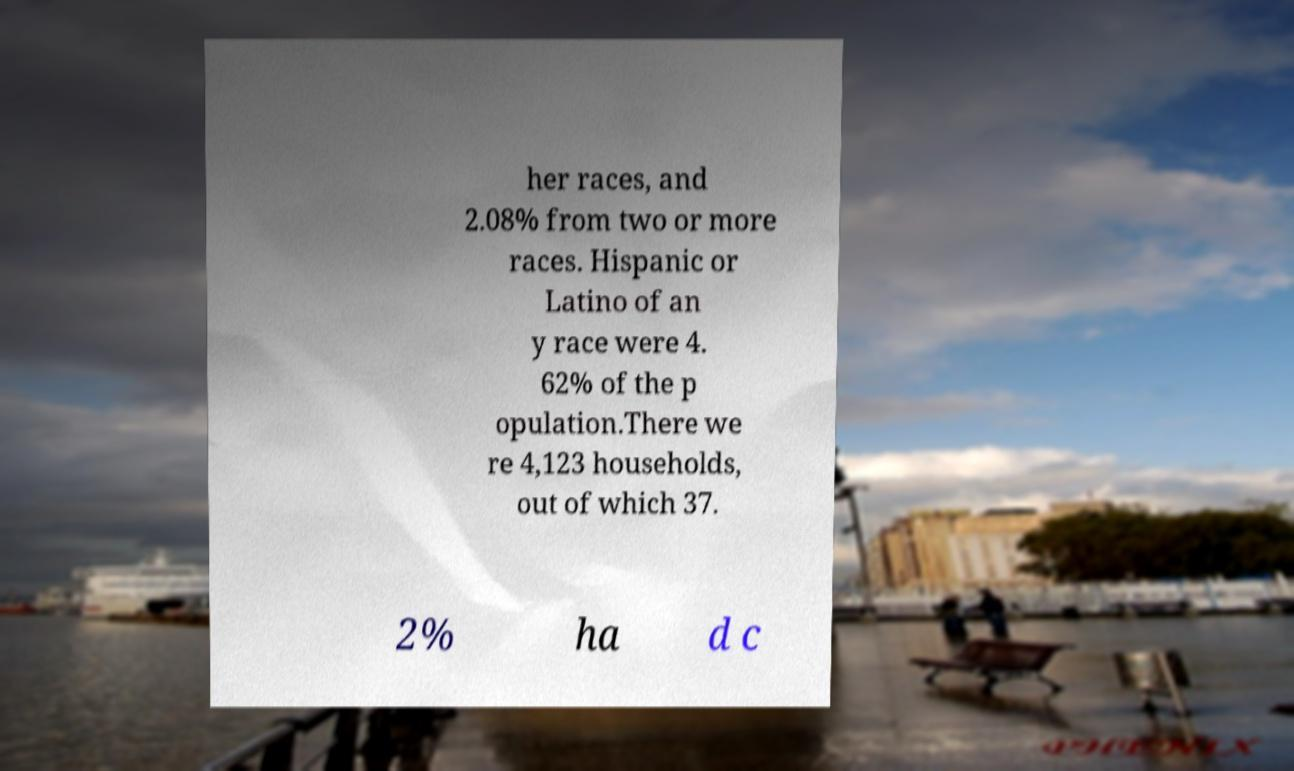Can you read and provide the text displayed in the image?This photo seems to have some interesting text. Can you extract and type it out for me? her races, and 2.08% from two or more races. Hispanic or Latino of an y race were 4. 62% of the p opulation.There we re 4,123 households, out of which 37. 2% ha d c 